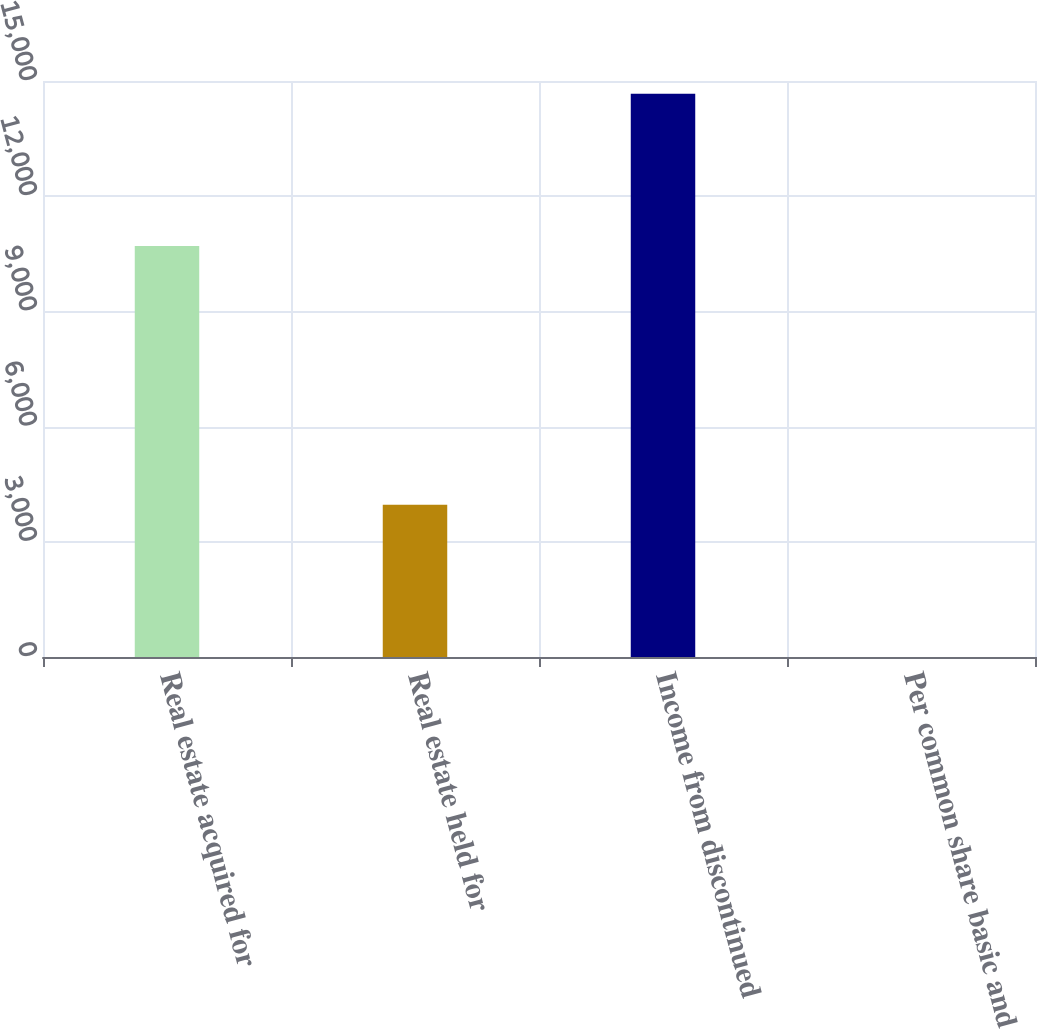<chart> <loc_0><loc_0><loc_500><loc_500><bar_chart><fcel>Real estate acquired for<fcel>Real estate held for<fcel>Income from discontinued<fcel>Per common share basic and<nl><fcel>10703<fcel>3963<fcel>14666<fcel>0.15<nl></chart> 